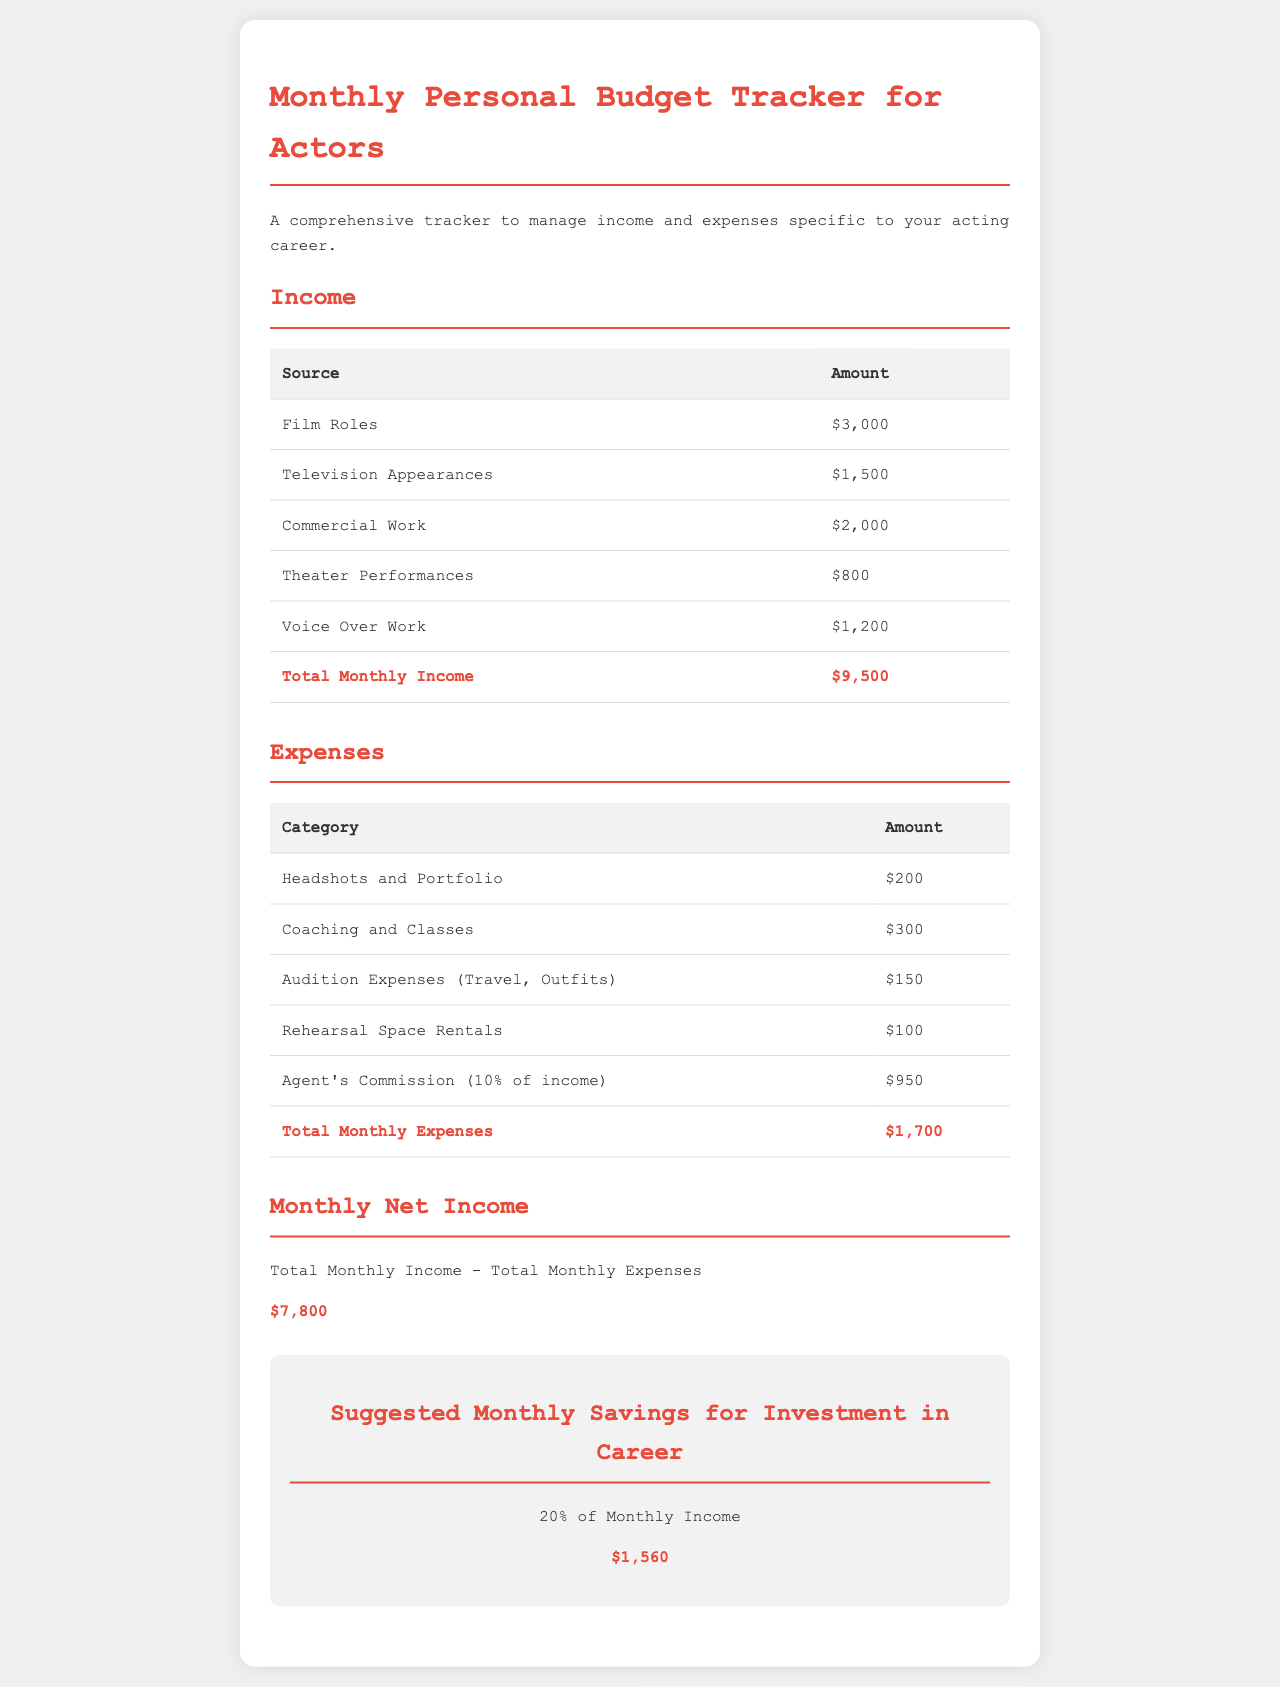what is the total monthly income? The total monthly income is provided in the document as the sum of all income sources, which is $3,000 + $1,500 + $2,000 + $800 + $1,200.
Answer: $9,500 what is the total monthly expense? The total monthly expense is provided in the document as the sum of all expense categories, which is $200 + $300 + $150 + $100 + $950.
Answer: $1,700 what is the monthly net income? The monthly net income is calculated as total monthly income minus total monthly expenses, which is $9,500 - $1,700.
Answer: $7,800 how much is suggested for monthly savings? The suggested monthly savings is calculated as 20% of the total monthly income, which is $9,500 * 0.20.
Answer: $1,560 what is the amount from film roles? The amount from film roles is listed as one of the income sources, which is $3,000.
Answer: $3,000 how much is the agent's commission? The agent's commission is stated as 10% of the total income, which totals $950.
Answer: $950 what is the expense for coaching and classes? The expense for coaching and classes is specified in the table of expenses as $300.
Answer: $300 what revenue source contributes the most? The revenue source that contributes the most is film roles, with an income of $3,000.
Answer: Film Roles what category has the lowest expense? The category with the lowest expense is rehearsal space rentals, listed as $100.
Answer: Rehearsal Space Rentals 